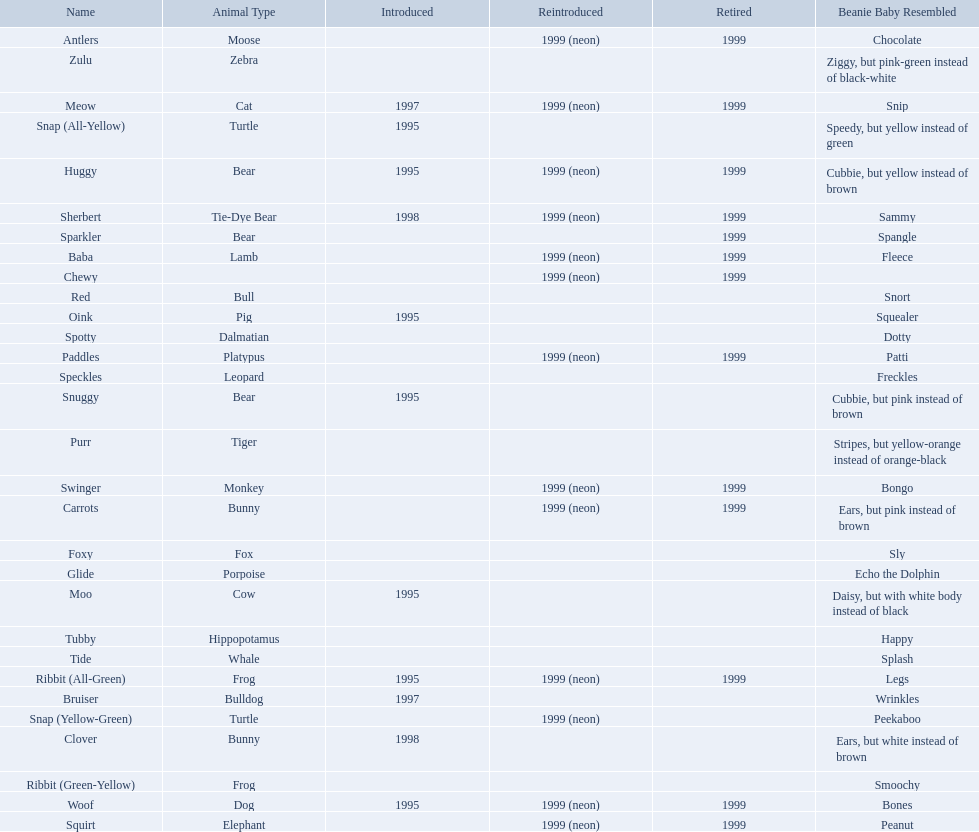What animals are pillow pals? Moose, Lamb, Bulldog, Bunny, Bunny, Fox, Porpoise, Bear, Cat, Cow, Pig, Platypus, Tiger, Bull, Frog, Frog, Tie-Dye Bear, Turtle, Turtle, Bear, Bear, Leopard, Dalmatian, Elephant, Monkey, Whale, Hippopotamus, Dog, Zebra. What is the name of the dalmatian? Spotty. Which of the listed pillow pals lack information in at least 3 categories? Chewy, Foxy, Glide, Purr, Red, Ribbit (Green-Yellow), Speckles, Spotty, Tide, Tubby, Zulu. Of those, which one lacks information in the animal type category? Chewy. 